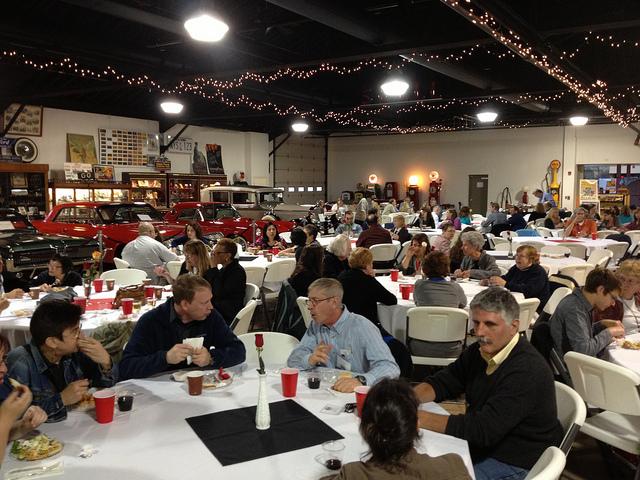What is on the ceiling?
Answer briefly. Lights. What are the event's theme colors?
Short answer required. Red white black. What's in the back of the room?
Give a very brief answer. Cars. 